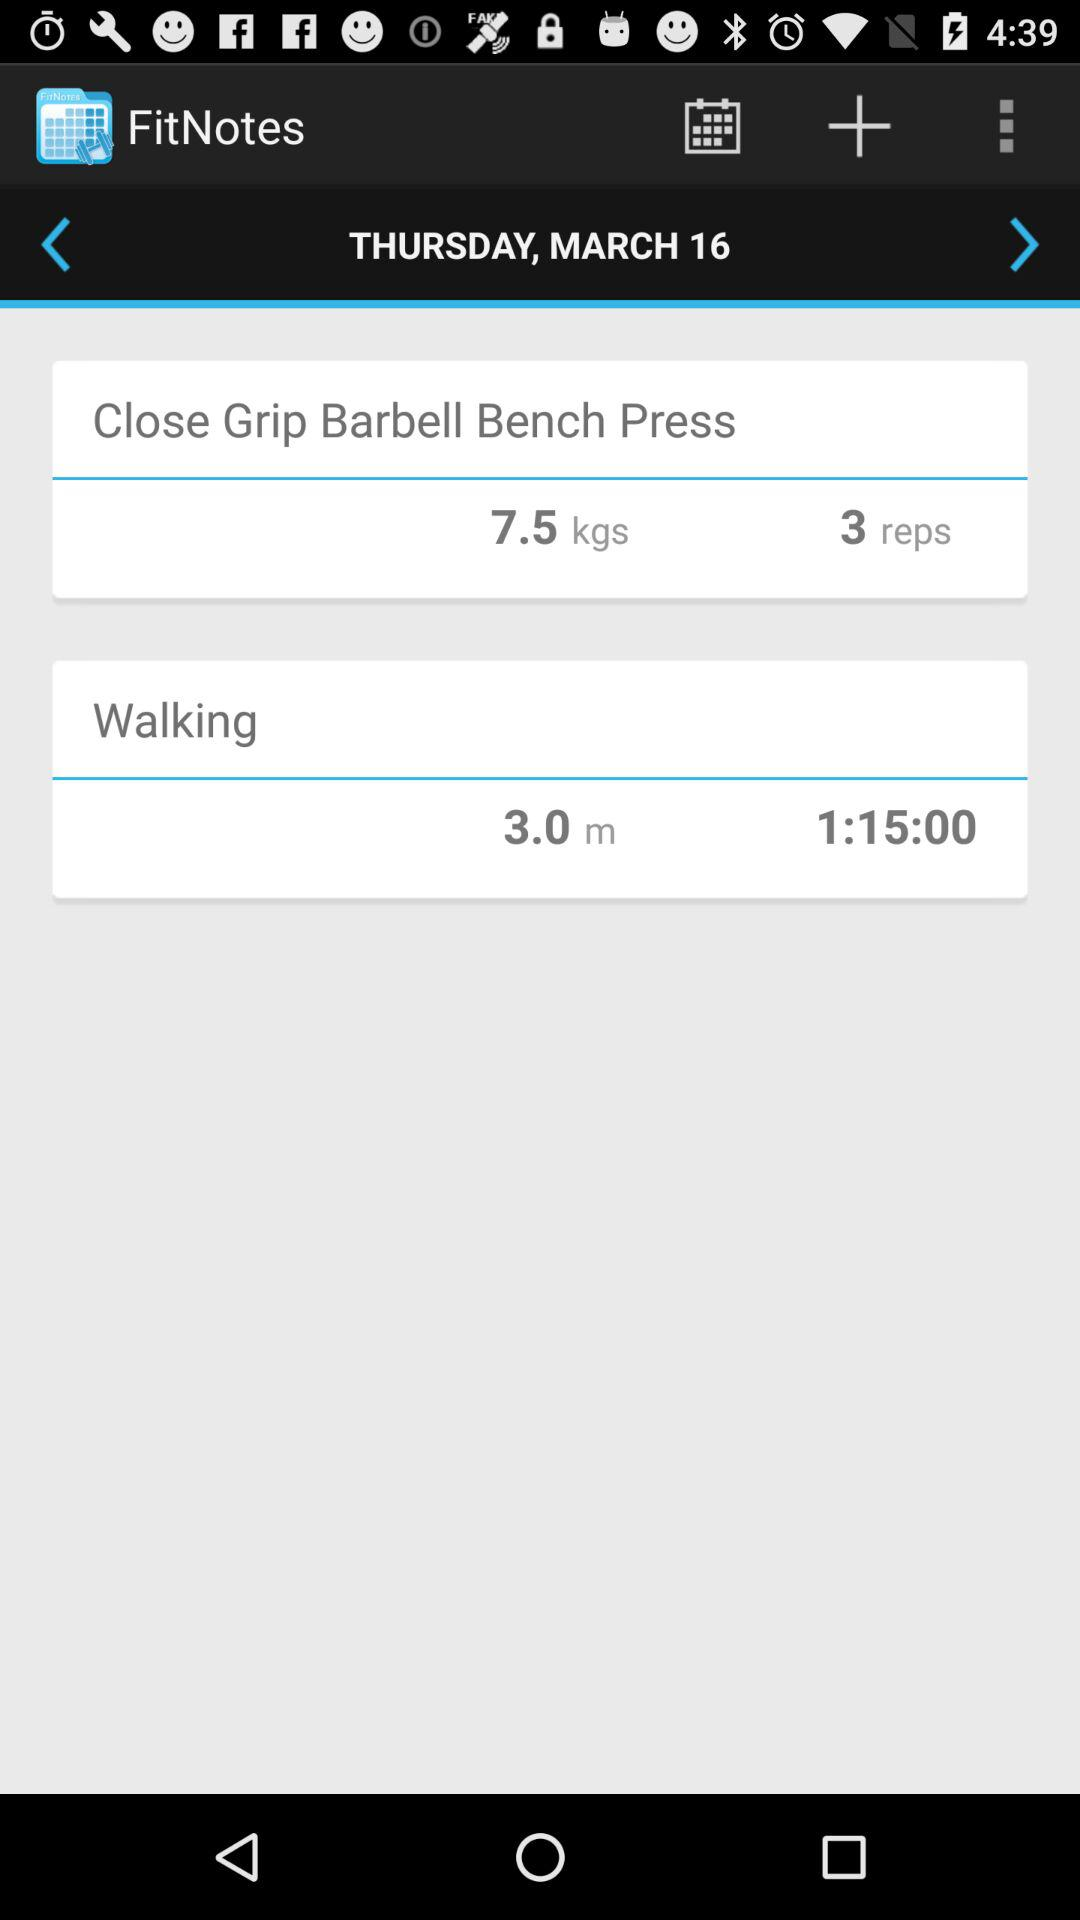How many reps are there? There are 3 reps. 